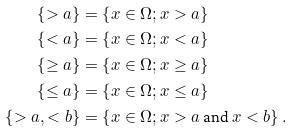<formula> <loc_0><loc_0><loc_500><loc_500>\left \{ > a \right \} & = \left \{ x \in \Omega ; x > a \right \} \\ \left \{ < a \right \} & = \left \{ x \in \Omega ; x < a \right \} \\ \left \{ \geq a \right \} & = \left \{ x \in \Omega ; x \geq a \right \} \\ \left \{ \leq a \right \} & = \left \{ x \in \Omega ; x \leq a \right \} \\ \left \{ > a , < b \right \} & = \left \{ x \in \Omega ; x > a \text { and } x < b \right \} .</formula> 